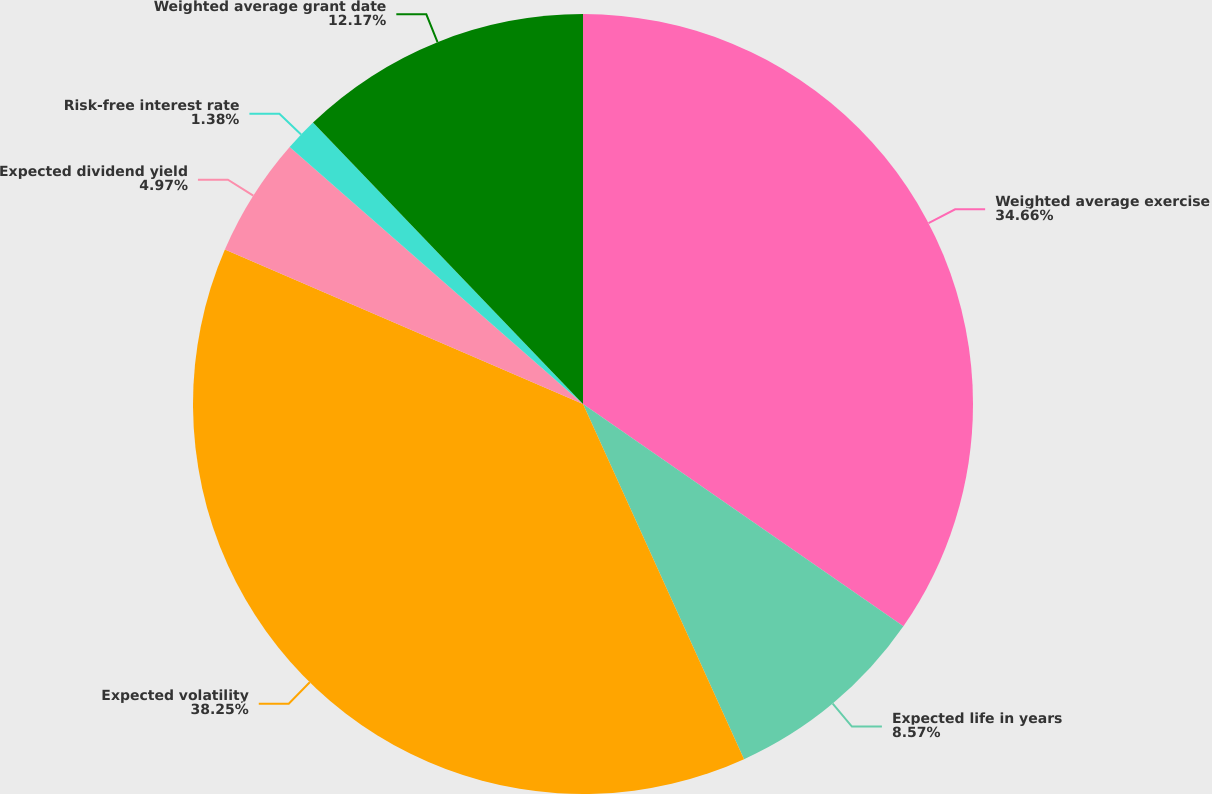<chart> <loc_0><loc_0><loc_500><loc_500><pie_chart><fcel>Weighted average exercise<fcel>Expected life in years<fcel>Expected volatility<fcel>Expected dividend yield<fcel>Risk-free interest rate<fcel>Weighted average grant date<nl><fcel>34.66%<fcel>8.57%<fcel>38.26%<fcel>4.97%<fcel>1.38%<fcel>12.17%<nl></chart> 